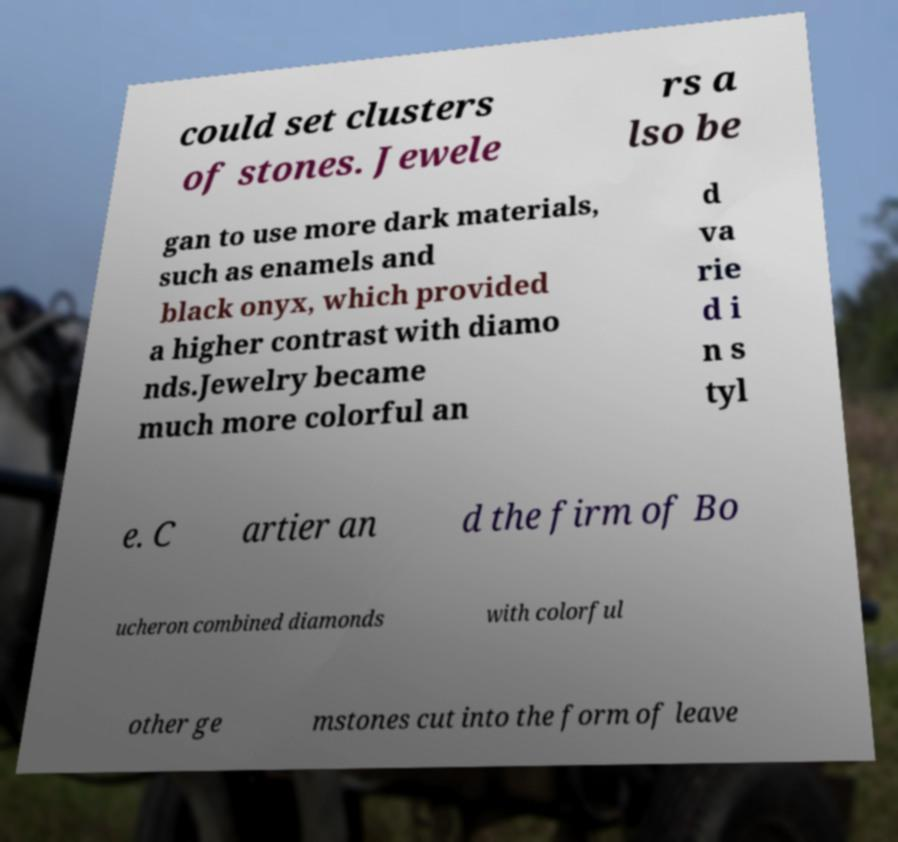Please read and relay the text visible in this image. What does it say? could set clusters of stones. Jewele rs a lso be gan to use more dark materials, such as enamels and black onyx, which provided a higher contrast with diamo nds.Jewelry became much more colorful an d va rie d i n s tyl e. C artier an d the firm of Bo ucheron combined diamonds with colorful other ge mstones cut into the form of leave 